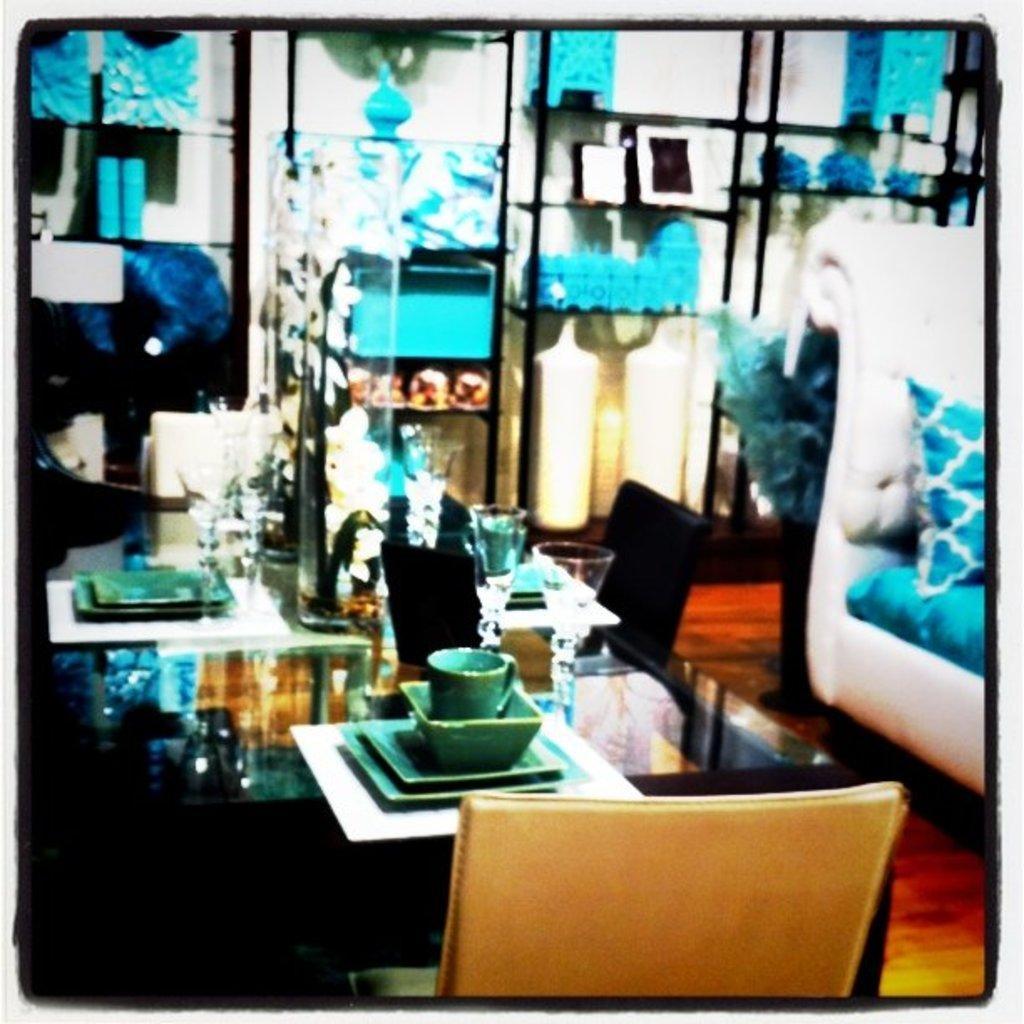How would you summarize this image in a sentence or two? The picture is taken in a room. In the foreground of the picture there is a table and chair. On the table there are plates, glasses and flowers. On the right there is a couch, on the couch there is a pillow. In the background, in the shells there are decorative, frames flowers and other objects. 